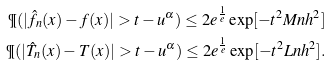<formula> <loc_0><loc_0><loc_500><loc_500>\P ( | \hat { f } _ { n } ( x ) - f ( x ) | > t - u ^ { \alpha } ) \leq 2 e ^ { \frac { 1 } { e } } \exp [ - t ^ { 2 } M n h ^ { 2 } ] \\ \P ( | \hat { T } _ { n } ( x ) - T ( x ) | > t - u ^ { \alpha } ) \leq 2 e ^ { \frac { 1 } { e } } \exp [ - t ^ { 2 } L n h ^ { 2 } ] \/ .</formula> 